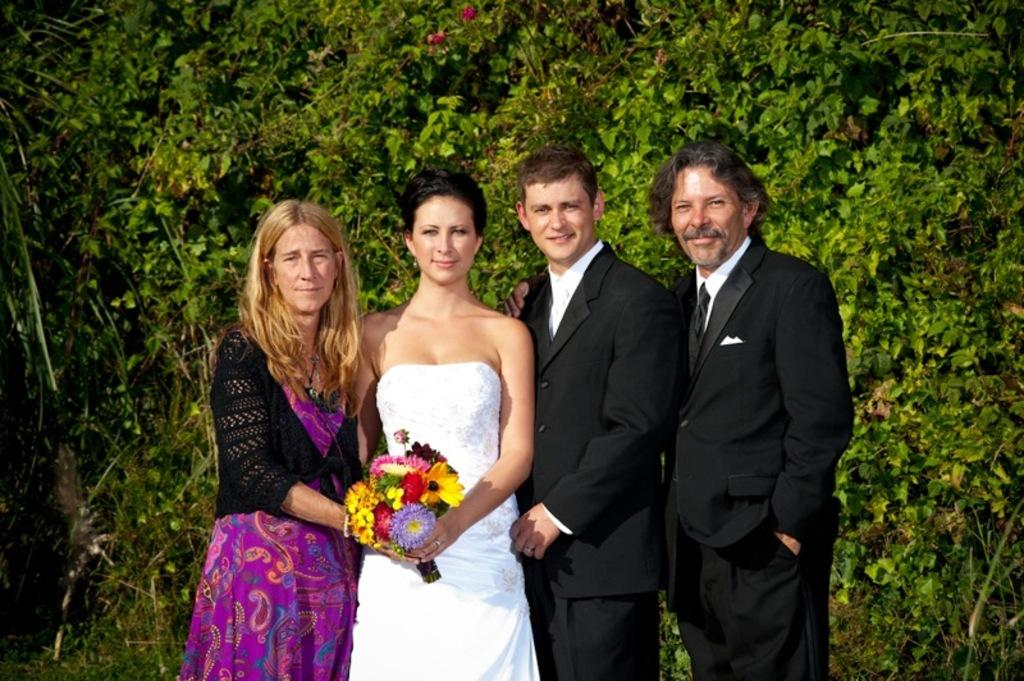How many people are in the image? There are four people standing in the image. What is the facial expression of the people in the image? The people are smiling. What are two of the women holding in the image? Two women are holding a flower bouquet. What can be seen in the background of the image? There are trees, leaves, and flowers visible in the background of the image. What type of twig can be seen in the hands of one of the people in the image? There is no twig visible in the hands of any of the people in the image. How does the concept of friction relate to the people's interaction in the image? The concept of friction is not relevant to the people's interaction in the image, as it involves the resistance between two surfaces in contact. --- Facts: 1. There is a car in the image. 2. The car is red. 3. The car has four wheels. 4. There is a road in the image. 5. The road is paved. Absurd Topics: parrot, sand, mountain Conversation: What is the main subject of the image? The main subject of the image is a car. What color is the car? The car is red. How many wheels does the car have? The car has four wheels. What type of surface is visible in the image? There is a paved road in the image. Reasoning: Let's think step by step in order to produce the conversation. We start by identifying the main subject of the image, which is the car. Then, we describe specific features of the car, such as its color and the number of wheels. Finally, we describe the type of surface visible in the image, which is a paved road. Absurd Question/Answer: Can you see a parrot perched on the car's roof in the image? No, there is no parrot visible in the image. Is the car driving on a sandy beach or near a mountain in the image? No, the car is on a paved road, and there is no indication of a sandy beach or mountain in the image. 